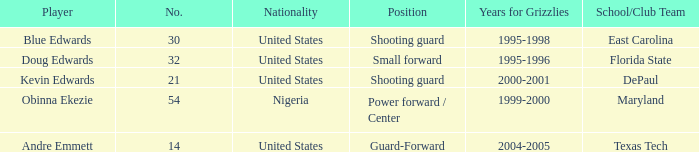When was the school/club team for grizzles was maryland 1999-2000. 